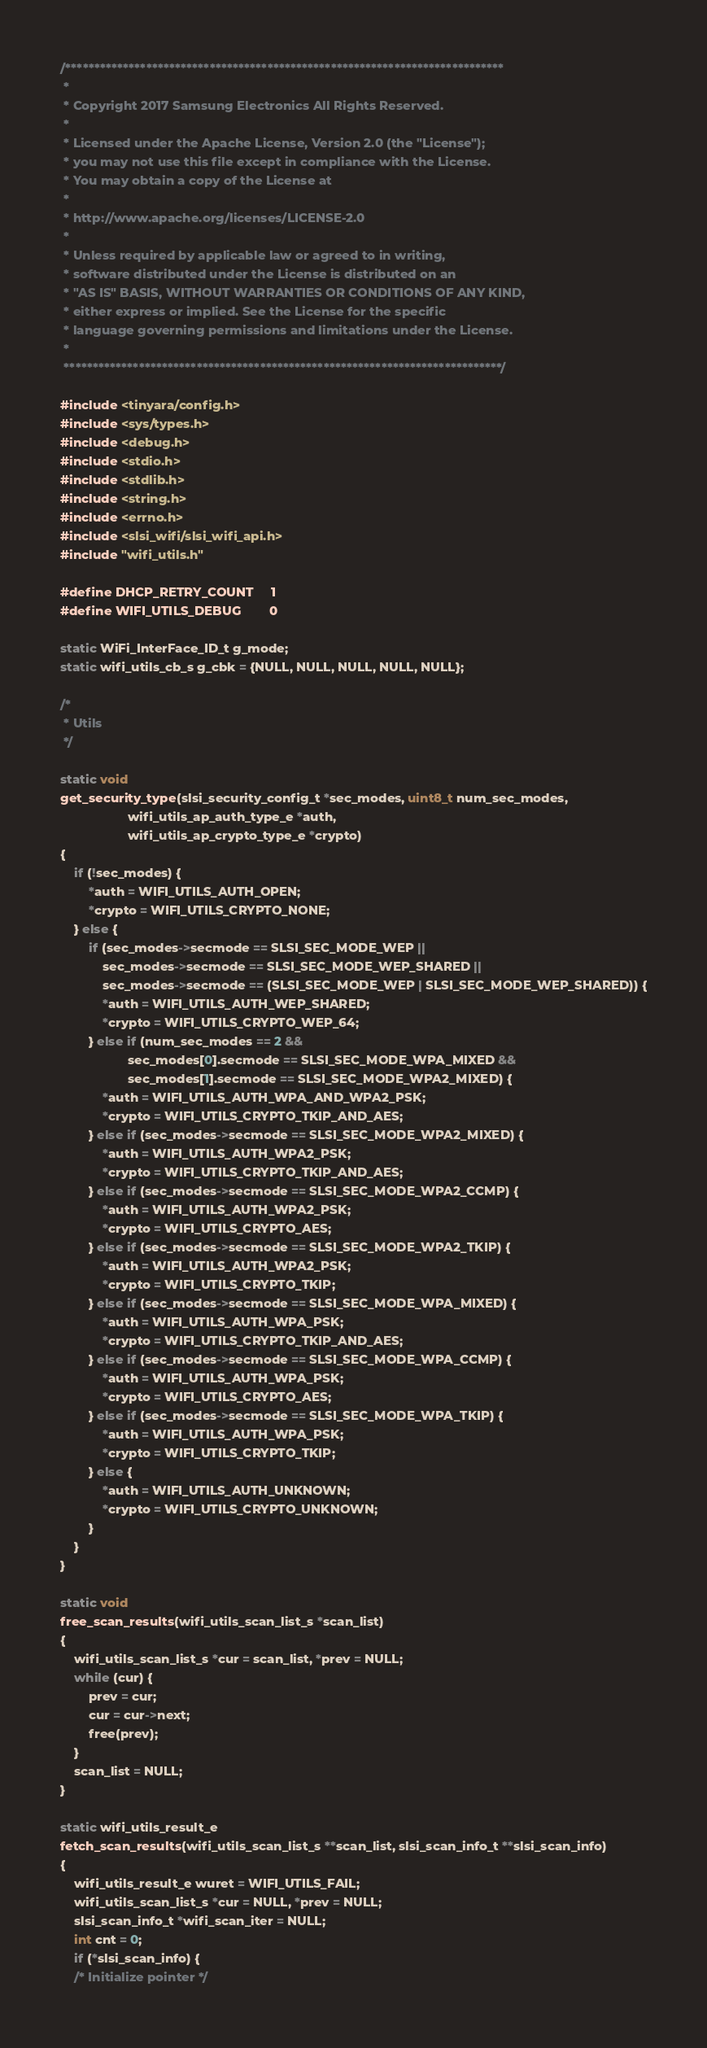<code> <loc_0><loc_0><loc_500><loc_500><_C_>/****************************************************************************
 *
 * Copyright 2017 Samsung Electronics All Rights Reserved.
 *
 * Licensed under the Apache License, Version 2.0 (the "License");
 * you may not use this file except in compliance with the License.
 * You may obtain a copy of the License at
 *
 * http://www.apache.org/licenses/LICENSE-2.0
 *
 * Unless required by applicable law or agreed to in writing,
 * software distributed under the License is distributed on an
 * "AS IS" BASIS, WITHOUT WARRANTIES OR CONDITIONS OF ANY KIND,
 * either express or implied. See the License for the specific
 * language governing permissions and limitations under the License.
 *
 ****************************************************************************/

#include <tinyara/config.h>
#include <sys/types.h>
#include <debug.h>
#include <stdio.h>
#include <stdlib.h>
#include <string.h>
#include <errno.h>
#include <slsi_wifi/slsi_wifi_api.h>
#include "wifi_utils.h"

#define DHCP_RETRY_COUNT		1
#define WIFI_UTILS_DEBUG        0

static WiFi_InterFace_ID_t g_mode;
static wifi_utils_cb_s g_cbk = {NULL, NULL, NULL, NULL, NULL};

/*
 * Utils
 */

static void
get_security_type(slsi_security_config_t *sec_modes, uint8_t num_sec_modes,
				   wifi_utils_ap_auth_type_e *auth,
				   wifi_utils_ap_crypto_type_e *crypto)
{
	if (!sec_modes) {
		*auth = WIFI_UTILS_AUTH_OPEN;
		*crypto = WIFI_UTILS_CRYPTO_NONE;
	} else {
		if (sec_modes->secmode == SLSI_SEC_MODE_WEP ||
			sec_modes->secmode == SLSI_SEC_MODE_WEP_SHARED ||
			sec_modes->secmode == (SLSI_SEC_MODE_WEP | SLSI_SEC_MODE_WEP_SHARED)) {
			*auth = WIFI_UTILS_AUTH_WEP_SHARED;
			*crypto = WIFI_UTILS_CRYPTO_WEP_64;
		} else if (num_sec_modes == 2 &&
				   sec_modes[0].secmode == SLSI_SEC_MODE_WPA_MIXED &&
				   sec_modes[1].secmode == SLSI_SEC_MODE_WPA2_MIXED) {
			*auth = WIFI_UTILS_AUTH_WPA_AND_WPA2_PSK;
			*crypto = WIFI_UTILS_CRYPTO_TKIP_AND_AES;
		} else if (sec_modes->secmode == SLSI_SEC_MODE_WPA2_MIXED) {
			*auth = WIFI_UTILS_AUTH_WPA2_PSK;
			*crypto = WIFI_UTILS_CRYPTO_TKIP_AND_AES;
		} else if (sec_modes->secmode == SLSI_SEC_MODE_WPA2_CCMP) {
			*auth = WIFI_UTILS_AUTH_WPA2_PSK;
			*crypto = WIFI_UTILS_CRYPTO_AES;
		} else if (sec_modes->secmode == SLSI_SEC_MODE_WPA2_TKIP) {
			*auth = WIFI_UTILS_AUTH_WPA2_PSK;
			*crypto = WIFI_UTILS_CRYPTO_TKIP;
		} else if (sec_modes->secmode == SLSI_SEC_MODE_WPA_MIXED) {
			*auth = WIFI_UTILS_AUTH_WPA_PSK;
			*crypto = WIFI_UTILS_CRYPTO_TKIP_AND_AES;
		} else if (sec_modes->secmode == SLSI_SEC_MODE_WPA_CCMP) {
			*auth = WIFI_UTILS_AUTH_WPA_PSK;
			*crypto = WIFI_UTILS_CRYPTO_AES;
		} else if (sec_modes->secmode == SLSI_SEC_MODE_WPA_TKIP) {
			*auth = WIFI_UTILS_AUTH_WPA_PSK;
			*crypto = WIFI_UTILS_CRYPTO_TKIP;
		} else {
			*auth = WIFI_UTILS_AUTH_UNKNOWN;
			*crypto = WIFI_UTILS_CRYPTO_UNKNOWN;
		}
	}
}

static void
free_scan_results(wifi_utils_scan_list_s *scan_list)
{
	wifi_utils_scan_list_s *cur = scan_list, *prev = NULL;
	while (cur) {
		prev = cur;
		cur = cur->next;
		free(prev);
	}
	scan_list = NULL;
}

static wifi_utils_result_e
fetch_scan_results(wifi_utils_scan_list_s **scan_list, slsi_scan_info_t **slsi_scan_info)
{
	wifi_utils_result_e wuret = WIFI_UTILS_FAIL;
	wifi_utils_scan_list_s *cur = NULL, *prev = NULL;
	slsi_scan_info_t *wifi_scan_iter = NULL;
	int cnt = 0;
	if (*slsi_scan_info) {
	/* Initialize pointer */</code> 